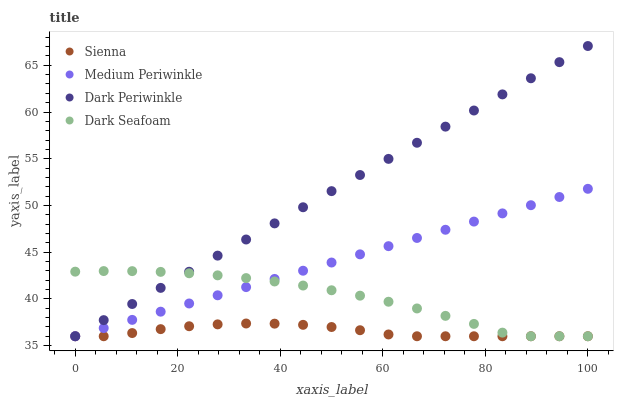Does Sienna have the minimum area under the curve?
Answer yes or no. Yes. Does Dark Periwinkle have the maximum area under the curve?
Answer yes or no. Yes. Does Dark Seafoam have the minimum area under the curve?
Answer yes or no. No. Does Dark Seafoam have the maximum area under the curve?
Answer yes or no. No. Is Dark Periwinkle the smoothest?
Answer yes or no. Yes. Is Dark Seafoam the roughest?
Answer yes or no. Yes. Is Medium Periwinkle the smoothest?
Answer yes or no. No. Is Medium Periwinkle the roughest?
Answer yes or no. No. Does Sienna have the lowest value?
Answer yes or no. Yes. Does Dark Periwinkle have the highest value?
Answer yes or no. Yes. Does Dark Seafoam have the highest value?
Answer yes or no. No. Does Dark Seafoam intersect Medium Periwinkle?
Answer yes or no. Yes. Is Dark Seafoam less than Medium Periwinkle?
Answer yes or no. No. Is Dark Seafoam greater than Medium Periwinkle?
Answer yes or no. No. 